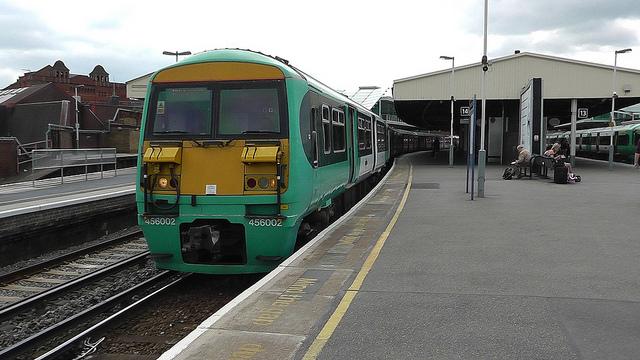How many people are waiting for the train?
Give a very brief answer. 2. Is this daytime?
Give a very brief answer. Yes. How many people are standing on the train platform?
Keep it brief. 0. Is there any luggage in the picture?
Answer briefly. Yes. How many tracks are to the right of the train?
Short answer required. 1. 